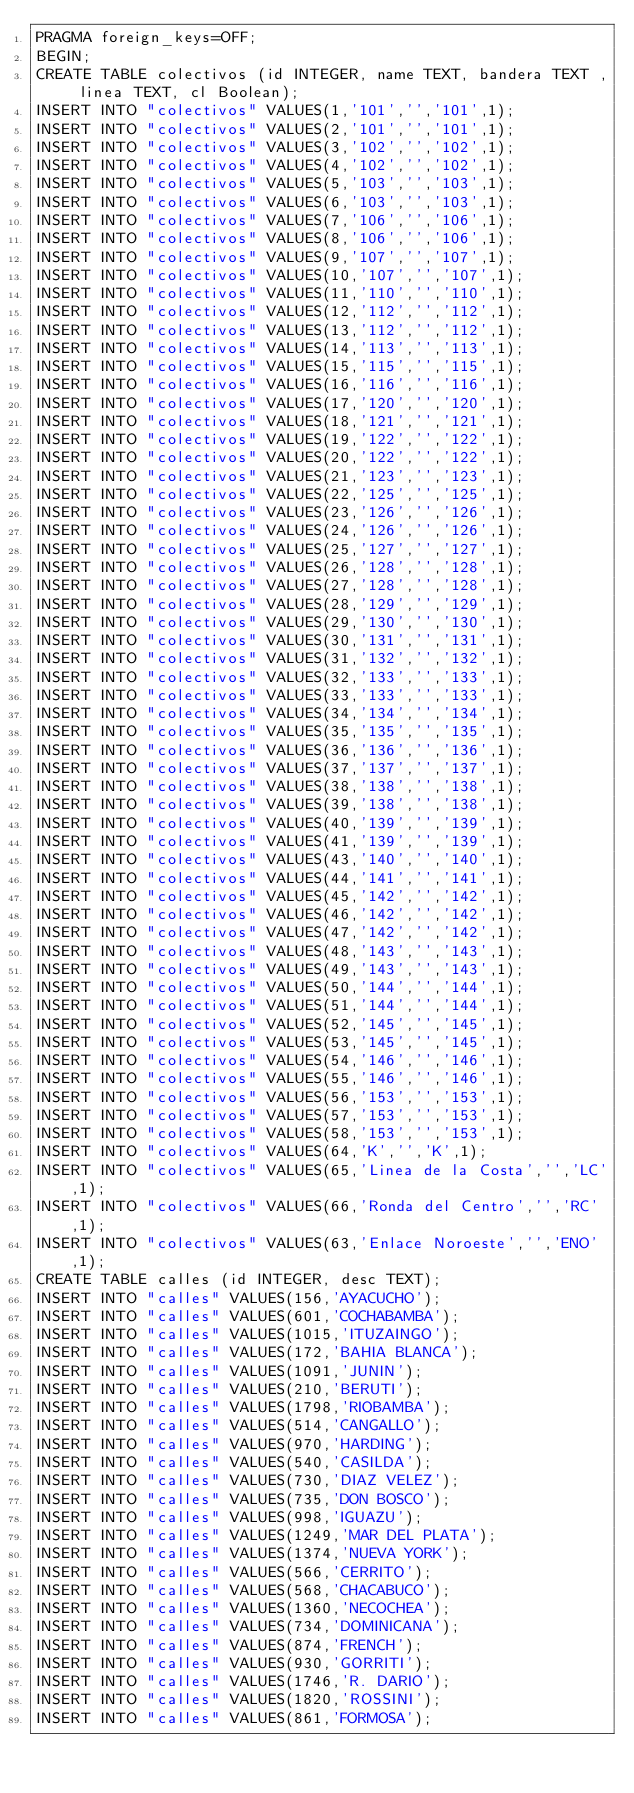<code> <loc_0><loc_0><loc_500><loc_500><_SQL_>PRAGMA foreign_keys=OFF;
BEGIN;
CREATE TABLE colectivos (id INTEGER, name TEXT, bandera TEXT , linea TEXT, cl Boolean);
INSERT INTO "colectivos" VALUES(1,'101','','101',1);
INSERT INTO "colectivos" VALUES(2,'101','','101',1);
INSERT INTO "colectivos" VALUES(3,'102','','102',1);
INSERT INTO "colectivos" VALUES(4,'102','','102',1);
INSERT INTO "colectivos" VALUES(5,'103','','103',1);
INSERT INTO "colectivos" VALUES(6,'103','','103',1);
INSERT INTO "colectivos" VALUES(7,'106','','106',1);
INSERT INTO "colectivos" VALUES(8,'106','','106',1);
INSERT INTO "colectivos" VALUES(9,'107','','107',1);
INSERT INTO "colectivos" VALUES(10,'107','','107',1);
INSERT INTO "colectivos" VALUES(11,'110','','110',1);
INSERT INTO "colectivos" VALUES(12,'112','','112',1);
INSERT INTO "colectivos" VALUES(13,'112','','112',1);
INSERT INTO "colectivos" VALUES(14,'113','','113',1);
INSERT INTO "colectivos" VALUES(15,'115','','115',1);
INSERT INTO "colectivos" VALUES(16,'116','','116',1);
INSERT INTO "colectivos" VALUES(17,'120','','120',1);
INSERT INTO "colectivos" VALUES(18,'121','','121',1);
INSERT INTO "colectivos" VALUES(19,'122','','122',1);
INSERT INTO "colectivos" VALUES(20,'122','','122',1);
INSERT INTO "colectivos" VALUES(21,'123','','123',1);
INSERT INTO "colectivos" VALUES(22,'125','','125',1);
INSERT INTO "colectivos" VALUES(23,'126','','126',1);
INSERT INTO "colectivos" VALUES(24,'126','','126',1);
INSERT INTO "colectivos" VALUES(25,'127','','127',1);
INSERT INTO "colectivos" VALUES(26,'128','','128',1);
INSERT INTO "colectivos" VALUES(27,'128','','128',1);
INSERT INTO "colectivos" VALUES(28,'129','','129',1);
INSERT INTO "colectivos" VALUES(29,'130','','130',1);
INSERT INTO "colectivos" VALUES(30,'131','','131',1);
INSERT INTO "colectivos" VALUES(31,'132','','132',1);
INSERT INTO "colectivos" VALUES(32,'133','','133',1);
INSERT INTO "colectivos" VALUES(33,'133','','133',1);
INSERT INTO "colectivos" VALUES(34,'134','','134',1);
INSERT INTO "colectivos" VALUES(35,'135','','135',1);
INSERT INTO "colectivos" VALUES(36,'136','','136',1);
INSERT INTO "colectivos" VALUES(37,'137','','137',1);
INSERT INTO "colectivos" VALUES(38,'138','','138',1);
INSERT INTO "colectivos" VALUES(39,'138','','138',1);
INSERT INTO "colectivos" VALUES(40,'139','','139',1);
INSERT INTO "colectivos" VALUES(41,'139','','139',1);
INSERT INTO "colectivos" VALUES(43,'140','','140',1);
INSERT INTO "colectivos" VALUES(44,'141','','141',1);
INSERT INTO "colectivos" VALUES(45,'142','','142',1);
INSERT INTO "colectivos" VALUES(46,'142','','142',1);
INSERT INTO "colectivos" VALUES(47,'142','','142',1);
INSERT INTO "colectivos" VALUES(48,'143','','143',1);
INSERT INTO "colectivos" VALUES(49,'143','','143',1);
INSERT INTO "colectivos" VALUES(50,'144','','144',1);
INSERT INTO "colectivos" VALUES(51,'144','','144',1);
INSERT INTO "colectivos" VALUES(52,'145','','145',1);
INSERT INTO "colectivos" VALUES(53,'145','','145',1);
INSERT INTO "colectivos" VALUES(54,'146','','146',1);
INSERT INTO "colectivos" VALUES(55,'146','','146',1);
INSERT INTO "colectivos" VALUES(56,'153','','153',1);
INSERT INTO "colectivos" VALUES(57,'153','','153',1);
INSERT INTO "colectivos" VALUES(58,'153','','153',1);
INSERT INTO "colectivos" VALUES(64,'K','','K',1);
INSERT INTO "colectivos" VALUES(65,'Linea de la Costa','','LC',1);
INSERT INTO "colectivos" VALUES(66,'Ronda del Centro','','RC',1);
INSERT INTO "colectivos" VALUES(63,'Enlace Noroeste','','ENO',1);
CREATE TABLE calles (id INTEGER, desc TEXT);
INSERT INTO "calles" VALUES(156,'AYACUCHO');
INSERT INTO "calles" VALUES(601,'COCHABAMBA');
INSERT INTO "calles" VALUES(1015,'ITUZAINGO');
INSERT INTO "calles" VALUES(172,'BAHIA BLANCA');
INSERT INTO "calles" VALUES(1091,'JUNIN');
INSERT INTO "calles" VALUES(210,'BERUTI');
INSERT INTO "calles" VALUES(1798,'RIOBAMBA');
INSERT INTO "calles" VALUES(514,'CANGALLO');
INSERT INTO "calles" VALUES(970,'HARDING');
INSERT INTO "calles" VALUES(540,'CASILDA');
INSERT INTO "calles" VALUES(730,'DIAZ VELEZ');
INSERT INTO "calles" VALUES(735,'DON BOSCO');
INSERT INTO "calles" VALUES(998,'IGUAZU');
INSERT INTO "calles" VALUES(1249,'MAR DEL PLATA');
INSERT INTO "calles" VALUES(1374,'NUEVA YORK');
INSERT INTO "calles" VALUES(566,'CERRITO');
INSERT INTO "calles" VALUES(568,'CHACABUCO');
INSERT INTO "calles" VALUES(1360,'NECOCHEA');
INSERT INTO "calles" VALUES(734,'DOMINICANA');
INSERT INTO "calles" VALUES(874,'FRENCH');
INSERT INTO "calles" VALUES(930,'GORRITI');
INSERT INTO "calles" VALUES(1746,'R. DARIO');
INSERT INTO "calles" VALUES(1820,'ROSSINI');
INSERT INTO "calles" VALUES(861,'FORMOSA');</code> 